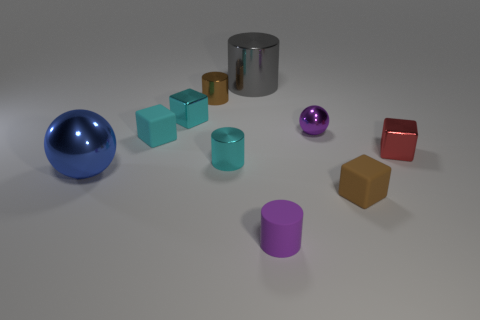There is a cylinder that is both behind the tiny purple matte thing and in front of the purple sphere; what is its color?
Provide a succinct answer. Cyan. What number of cylinders are rubber objects or big gray things?
Give a very brief answer. 2. There is a red metallic thing; is its shape the same as the brown object that is in front of the big blue metallic thing?
Make the answer very short. Yes. How big is the object that is in front of the tiny cyan metallic cylinder and on the right side of the tiny metal ball?
Your response must be concise. Small. What shape is the blue object?
Provide a succinct answer. Sphere. Is there a red shiny block that is behind the purple thing that is behind the purple cylinder?
Ensure brevity in your answer.  No. What number of tiny objects are left of the cube that is in front of the small red thing?
Keep it short and to the point. 6. What is the material of the brown cube that is the same size as the purple rubber object?
Give a very brief answer. Rubber. There is a tiny brown thing behind the red thing; does it have the same shape as the gray metal thing?
Offer a very short reply. Yes. Are there more balls that are on the right side of the tiny red cube than blue shiny objects that are to the right of the tiny brown shiny object?
Your response must be concise. No. 